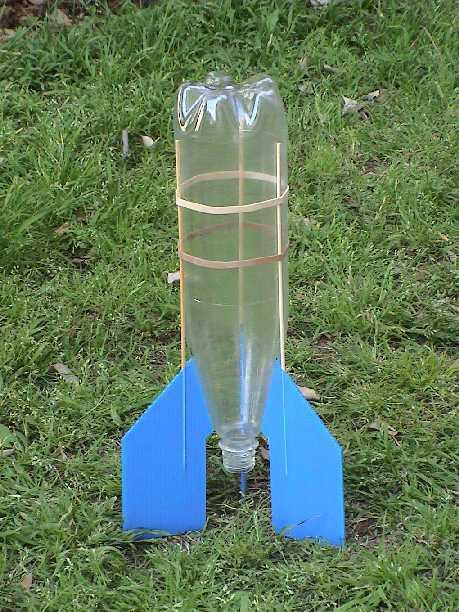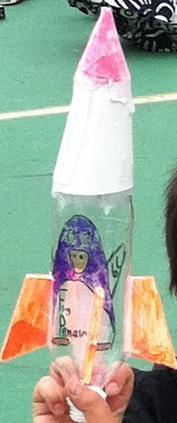The first image is the image on the left, the second image is the image on the right. Evaluate the accuracy of this statement regarding the images: "The left image features one inverted bottle with fins on its base to create a rocket ship.". Is it true? Answer yes or no. Yes. The first image is the image on the left, the second image is the image on the right. Analyze the images presented: Is the assertion "A person is holding the bottle rocket in one of the images." valid? Answer yes or no. Yes. 